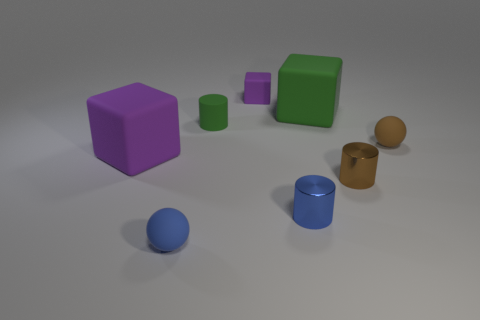Add 2 large yellow matte balls. How many objects exist? 10 Subtract all green matte cylinders. How many cylinders are left? 2 Subtract 1 cylinders. How many cylinders are left? 2 Subtract all purple cubes. How many cubes are left? 1 Subtract all yellow spheres. How many green cylinders are left? 1 Subtract all spheres. How many objects are left? 6 Subtract all gray cylinders. Subtract all blue blocks. How many cylinders are left? 3 Subtract all large cubes. Subtract all tiny green matte objects. How many objects are left? 5 Add 5 large purple rubber objects. How many large purple rubber objects are left? 6 Add 3 brown metal things. How many brown metal things exist? 4 